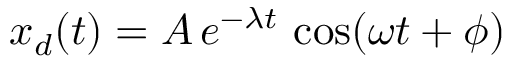Convert formula to latex. <formula><loc_0><loc_0><loc_500><loc_500>x _ { d } ( t ) = A \, e ^ { - \lambda t } \, \cos ( \omega t + \phi )</formula> 